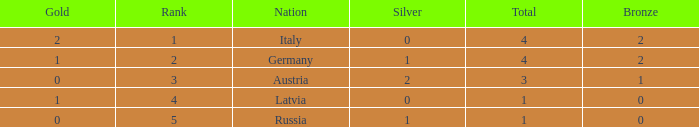What is the average number of silver medals for countries with 0 gold and rank under 3? None. 